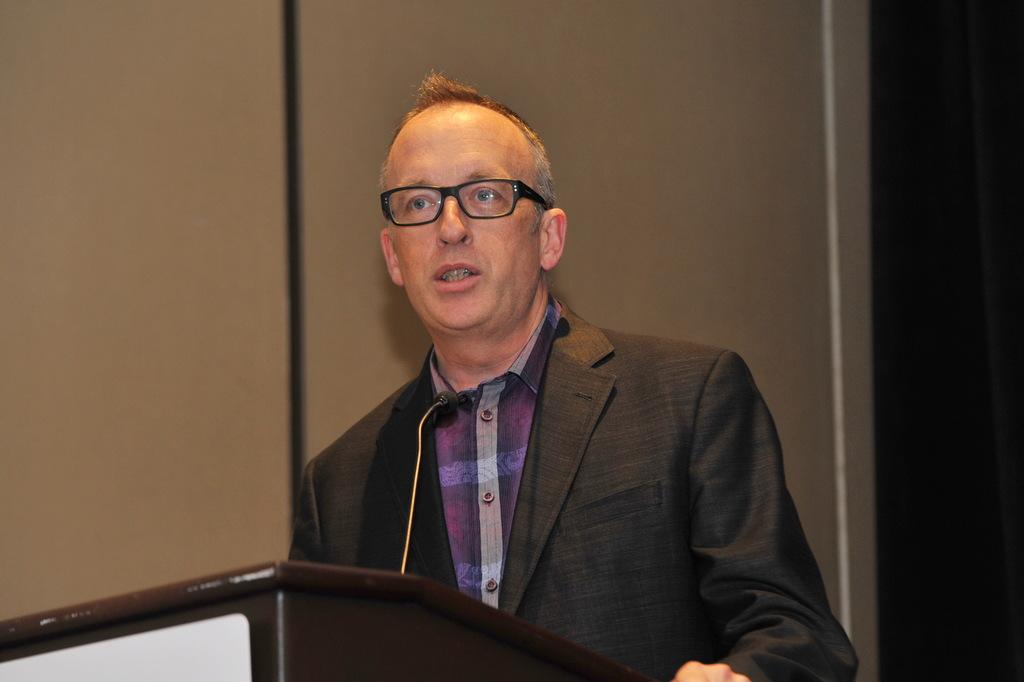Who or what is in the image? There is a person in the image. What is in front of the person? There is a podium in front of the person. What is used for amplifying the person's voice? A microphone is present near the person. What can be seen behind the person? There is a wall visible in the background of the image. Are there any fairies visible in the image? No, there are no fairies present in the image. What team does the person belong to in the image? The image does not provide any information about the person's team affiliation. 